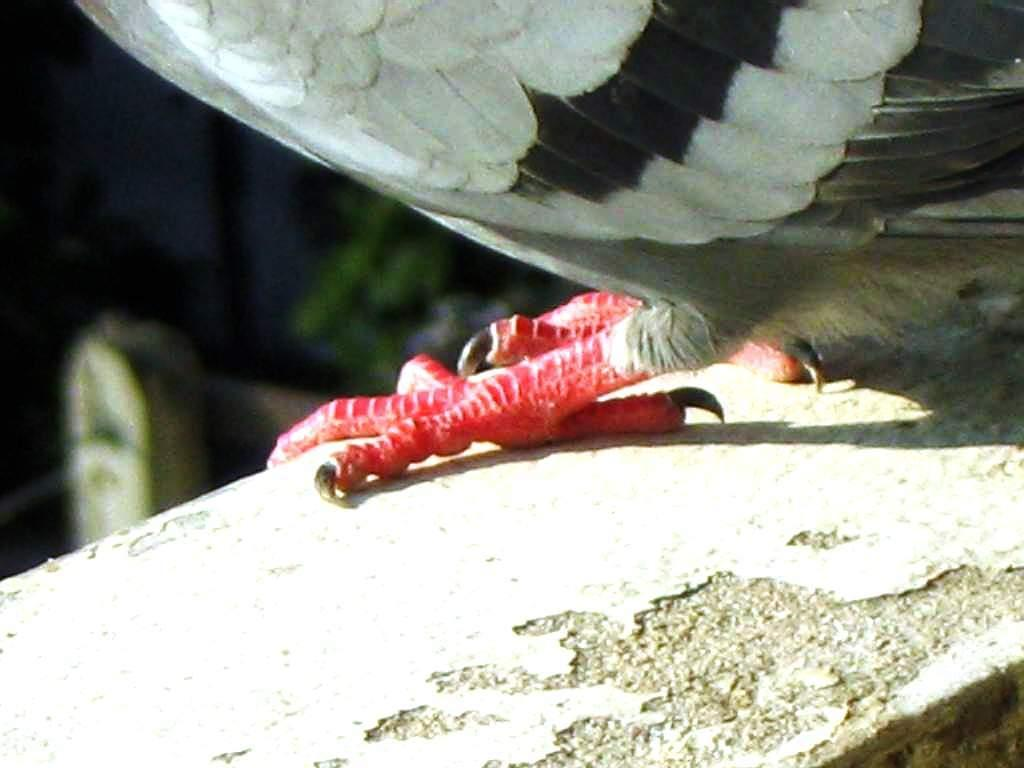What part of a bird can be seen in the image? There are legs of a bird visible in the image. Where is the bird located in the image? The bird is standing on a wall. Can you describe the background of the image? The background of the image is blurred. Is there a farmer holding an icicle in the image? There is no farmer or icicle present in the image. 